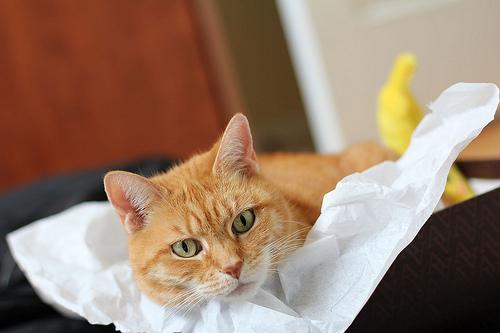How many cats are in the photo?
Give a very brief answer. 1. How many doors are open?
Give a very brief answer. 1. How many ears does the cat have?
Give a very brief answer. 2. How many cats are shown?
Give a very brief answer. 1. How many fruits are in the photo?
Give a very brief answer. 1. 